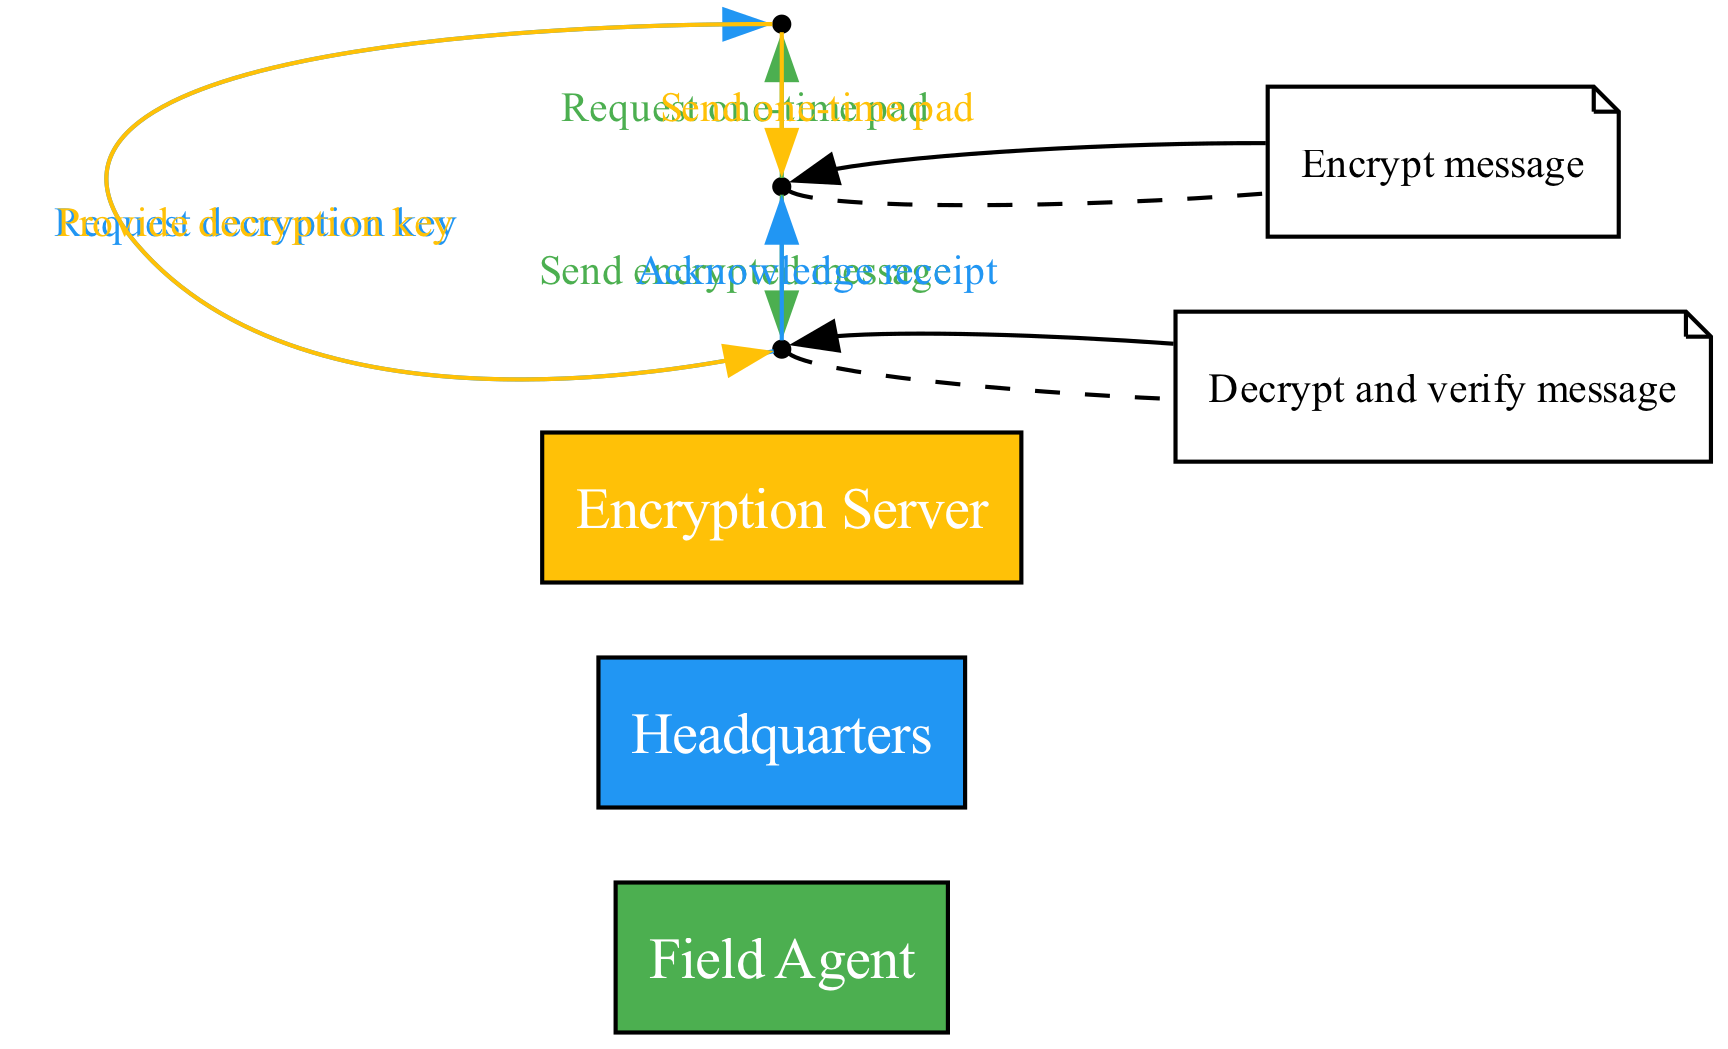What are the three actors involved in the protocol? The diagram lists three actors: Field Agent, Headquarters, and Encryption Server. These are the primary entities participating in the communication protocol.
Answer: Field Agent, Headquarters, Encryption Server How many total messages are exchanged in the protocol? By counting the arrows between the actors in the diagram, we see eight messages exchanged, demonstrating the interaction flow among the actors.
Answer: 8 Which actor requests the decryption key? The diagram indicates that Headquarters initiates the request for the decryption key by sending a message to the Encryption Server. This is essential for decrypting the received message.
Answer: Headquarters What action does the Field Agent perform after receiving the one-time pad? After receiving the one-time pad from the Encryption Server, the Field Agent performs the action of encrypting the message, which is depicted in the diagram.
Answer: Encrypt message What is the final message sent in the protocol? The last message indicated in the sequence diagram is the acknowledgment sent from Headquarters back to the Field Agent, confirming the receipt of the encrypted message.
Answer: Acknowledge receipt How does the Flow of Information progress from the Field Agent to the Headquarters? The Field Agent first requests a one-time pad, then encrypts the message using it, and sends the encrypted message to Headquarters, indicating a one-directional flow of information.
Answer: Encrypts message and sends Which actor sends the one-time pad? According to the sequence of messages in the diagram, the Encryption Server is responsible for sending the one-time pad back to the Field Agent after the request.
Answer: Encryption Server What is indicated by the self-message from the Field Agent? The self-message in the diagram signifies the internal process done by the Field Agent for encrypting the message, which indicates that the Field Agent is acting autonomously to secure communication.
Answer: Encrypt message 